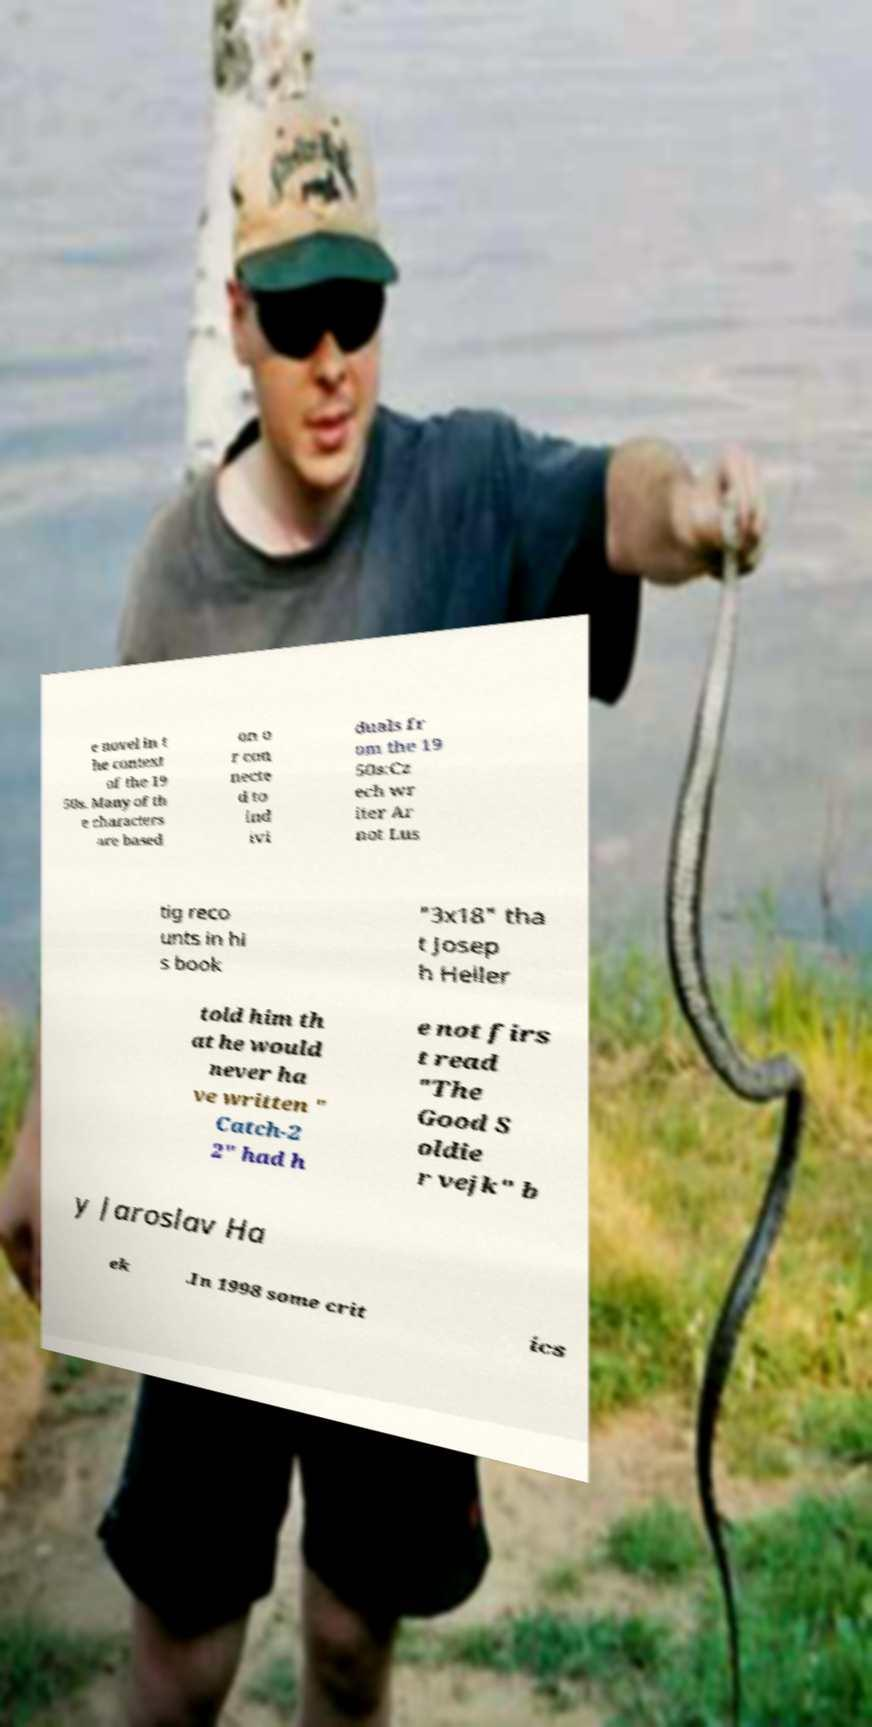Please read and relay the text visible in this image. What does it say? e novel in t he context of the 19 50s. Many of th e characters are based on o r con necte d to ind ivi duals fr om the 19 50s:Cz ech wr iter Ar not Lus tig reco unts in hi s book "3x18" tha t Josep h Heller told him th at he would never ha ve written " Catch-2 2" had h e not firs t read "The Good S oldie r vejk" b y Jaroslav Ha ek .In 1998 some crit ics 